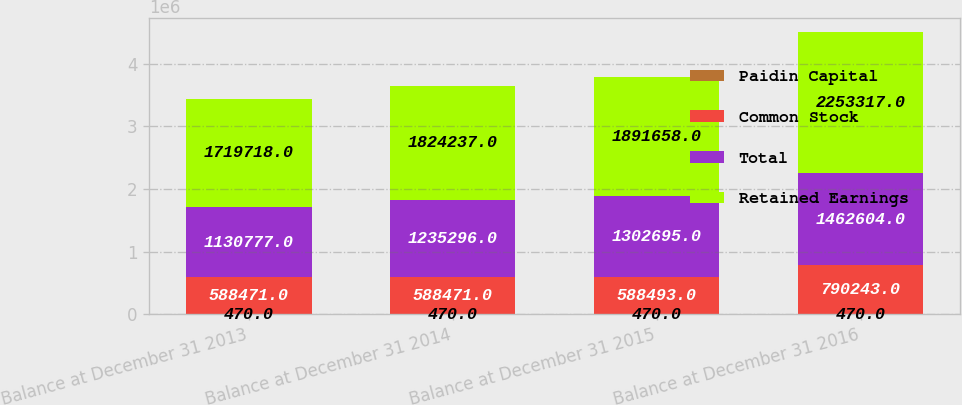<chart> <loc_0><loc_0><loc_500><loc_500><stacked_bar_chart><ecel><fcel>Balance at December 31 2013<fcel>Balance at December 31 2014<fcel>Balance at December 31 2015<fcel>Balance at December 31 2016<nl><fcel>Paidin Capital<fcel>470<fcel>470<fcel>470<fcel>470<nl><fcel>Common Stock<fcel>588471<fcel>588471<fcel>588493<fcel>790243<nl><fcel>Total<fcel>1.13078e+06<fcel>1.2353e+06<fcel>1.3027e+06<fcel>1.4626e+06<nl><fcel>Retained Earnings<fcel>1.71972e+06<fcel>1.82424e+06<fcel>1.89166e+06<fcel>2.25332e+06<nl></chart> 